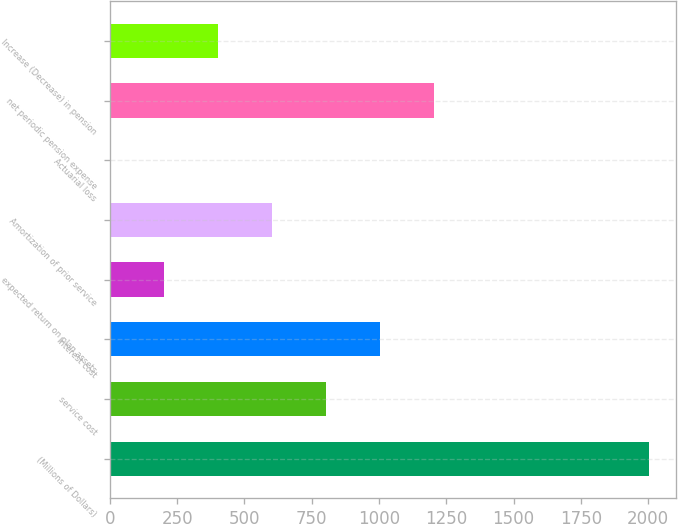<chart> <loc_0><loc_0><loc_500><loc_500><bar_chart><fcel>(Millions of Dollars)<fcel>service cost<fcel>Interest cost<fcel>expected return on plan assets<fcel>Amortization of prior service<fcel>Actuarial loss<fcel>net periodic pension expense<fcel>Increase (Decrease) in pension<nl><fcel>2004<fcel>801.9<fcel>1002.25<fcel>200.85<fcel>601.55<fcel>0.5<fcel>1202.6<fcel>401.2<nl></chart> 